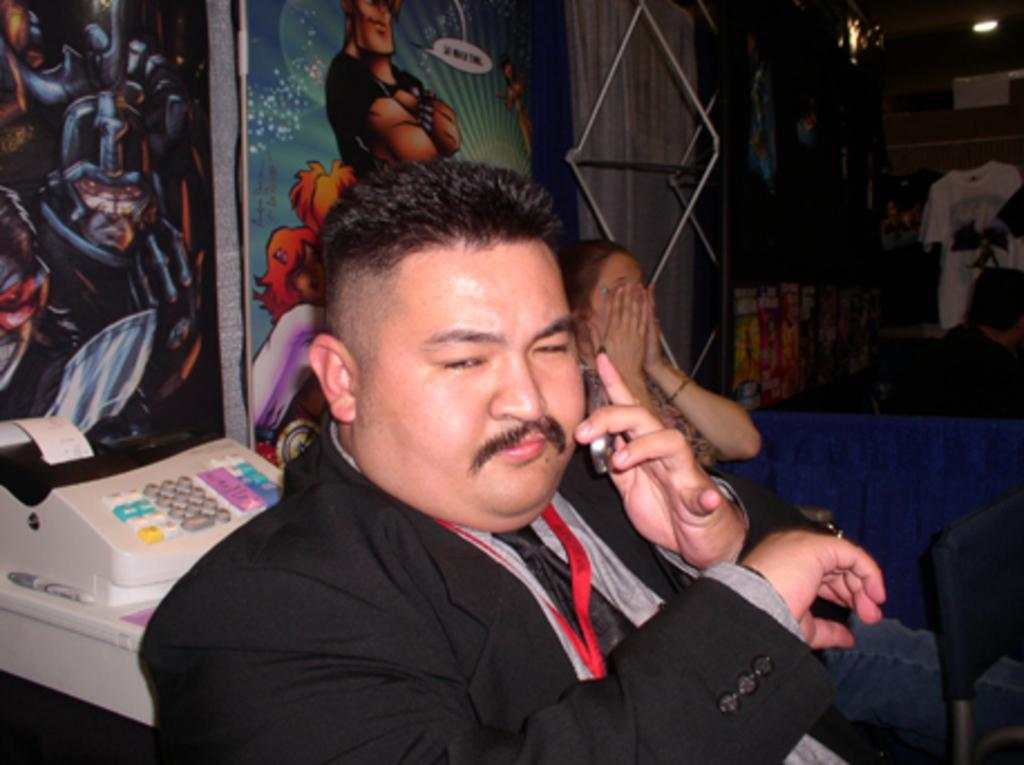What is the person in the center of the image holding? The person in the center of the image is holding a mobile phone. Can you describe the background of the image? In the background of the image, there is a person, a t-shirt, a wall, a door, prints, and posters. What might the person in the background be doing? It is not clear from the image what the person in the background is doing. What type of prints are visible in the background? The provided facts do not specify the type of prints visible in the background. What word is written on the sidewalk in the image? There is no sidewalk present in the image, so it is not possible to answer that question. 